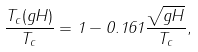<formula> <loc_0><loc_0><loc_500><loc_500>\frac { T _ { c } ( g H ) } { T _ { c } } = 1 - 0 . 1 6 1 \frac { \sqrt { g H } } { T _ { c } } ,</formula> 